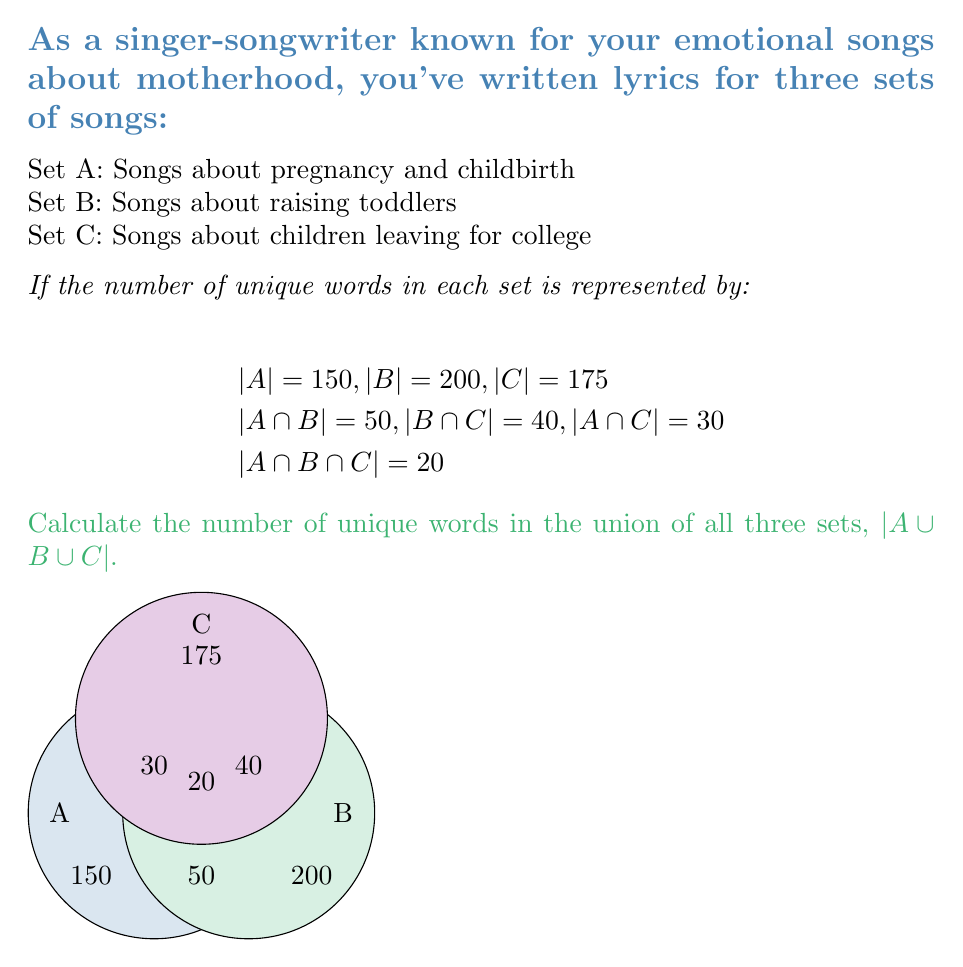Show me your answer to this math problem. To solve this problem, we'll use the Inclusion-Exclusion Principle for three sets:

$$|A \cup B \cup C| = |A| + |B| + |C| - |A \cap B| - |B \cap C| - |A \cap C| + |A \cap B \cap C|$$

Let's substitute the given values:

1) First, add the number of unique words in each set:
   $$|A| + |B| + |C| = 150 + 200 + 175 = 525$$

2) Subtract the intersections of two sets:
   $$|A \cap B| + |B \cap C| + |A \cap C| = 50 + 40 + 30 = 120$$
   $$525 - 120 = 405$$

3) Add back the intersection of all three sets to avoid double subtraction:
   $$405 + |A \cap B \cap C| = 405 + 20 = 425$$

Therefore, the number of unique words in the union of all three sets is 425.
Answer: 425 